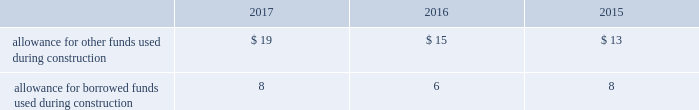Income taxes american water and its subsidiaries participate in a consolidated federal income tax return for u.s .
Tax purposes .
Members of the consolidated group are charged with the amount of federal income tax expense determined as if they filed separate returns .
Certain income and expense items are accounted for in different time periods for financial reporting than for income tax reporting purposes .
The company provides deferred income taxes on the difference between the tax basis of assets and liabilities and the amounts at which they are carried in the financial statements .
These deferred income taxes are based on the enacted tax rates expected to be in effect when these temporary differences are projected to reverse .
In addition , the regulated utility subsidiaries recognize regulatory assets and liabilities for the effect on revenues expected to be realized as the tax effects of temporary differences , previously flowed through to customers , reverse .
Investment tax credits have been deferred by the regulated utility subsidiaries and are being amortized to income over the average estimated service lives of the related assets .
The company recognizes accrued interest and penalties related to tax positions as a component of income tax expense and accounts for sales tax collected from customers and remitted to taxing authorities on a net basis .
See note 13 2014income taxes .
Allowance for funds used during construction afudc is a non-cash credit to income with a corresponding charge to utility plant that represents the cost of borrowed funds or a return on equity funds devoted to plant under construction .
The regulated utility subsidiaries record afudc to the extent permitted by the pucs .
The portion of afudc attributable to borrowed funds is shown as a reduction of interest , net in the accompanying consolidated statements of operations .
Any portion of afudc attributable to equity funds would be included in other income ( expenses ) in the accompanying consolidated statements of operations .
Afudc is summarized in the table for the years ended december 31: .
Environmental costs the company 2019s water and wastewater operations and the operations of its market-based businesses are subject to u.s .
Federal , state , local and foreign requirements relating to environmental protection , and as such , the company periodically becomes subject to environmental claims in the normal course of business .
Environmental expenditures that relate to current operations or provide a future benefit are expensed or capitalized as appropriate .
Remediation costs that relate to an existing condition caused by past operations are accrued , on an undiscounted basis , when it is probable that these costs will be incurred and can be reasonably estimated .
A conservation agreement entered into by a subsidiary of the company with the national oceanic and atmospheric administration in 2010 and amended in 2017 required the company to , among other provisions , implement certain measures to protect the steelhead trout and its habitat in the carmel river watershed in the state of california .
The company agreed to pay $ 1 million annually commencing in 2010 with the final payment being made in 2021 .
Remediation costs accrued amounted to $ 6 million and less than $ 1 million as of december 31 , 2017 and 2016 , respectively .
Derivative financial instruments the company uses derivative financial instruments for purposes of hedging exposures to fluctuations in interest rates .
These derivative contracts are entered into for periods consistent with the related underlying .
What percentage of total afudc in 2016 accounted for allowance for borrowed funds used during construction? 
Computations: (6 / (15 + 6))
Answer: 0.28571. Income taxes american water and its subsidiaries participate in a consolidated federal income tax return for u.s .
Tax purposes .
Members of the consolidated group are charged with the amount of federal income tax expense determined as if they filed separate returns .
Certain income and expense items are accounted for in different time periods for financial reporting than for income tax reporting purposes .
The company provides deferred income taxes on the difference between the tax basis of assets and liabilities and the amounts at which they are carried in the financial statements .
These deferred income taxes are based on the enacted tax rates expected to be in effect when these temporary differences are projected to reverse .
In addition , the regulated utility subsidiaries recognize regulatory assets and liabilities for the effect on revenues expected to be realized as the tax effects of temporary differences , previously flowed through to customers , reverse .
Investment tax credits have been deferred by the regulated utility subsidiaries and are being amortized to income over the average estimated service lives of the related assets .
The company recognizes accrued interest and penalties related to tax positions as a component of income tax expense and accounts for sales tax collected from customers and remitted to taxing authorities on a net basis .
See note 13 2014income taxes .
Allowance for funds used during construction afudc is a non-cash credit to income with a corresponding charge to utility plant that represents the cost of borrowed funds or a return on equity funds devoted to plant under construction .
The regulated utility subsidiaries record afudc to the extent permitted by the pucs .
The portion of afudc attributable to borrowed funds is shown as a reduction of interest , net in the accompanying consolidated statements of operations .
Any portion of afudc attributable to equity funds would be included in other income ( expenses ) in the accompanying consolidated statements of operations .
Afudc is summarized in the table for the years ended december 31: .
Environmental costs the company 2019s water and wastewater operations and the operations of its market-based businesses are subject to u.s .
Federal , state , local and foreign requirements relating to environmental protection , and as such , the company periodically becomes subject to environmental claims in the normal course of business .
Environmental expenditures that relate to current operations or provide a future benefit are expensed or capitalized as appropriate .
Remediation costs that relate to an existing condition caused by past operations are accrued , on an undiscounted basis , when it is probable that these costs will be incurred and can be reasonably estimated .
A conservation agreement entered into by a subsidiary of the company with the national oceanic and atmospheric administration in 2010 and amended in 2017 required the company to , among other provisions , implement certain measures to protect the steelhead trout and its habitat in the carmel river watershed in the state of california .
The company agreed to pay $ 1 million annually commencing in 2010 with the final payment being made in 2021 .
Remediation costs accrued amounted to $ 6 million and less than $ 1 million as of december 31 , 2017 and 2016 , respectively .
Derivative financial instruments the company uses derivative financial instruments for purposes of hedging exposures to fluctuations in interest rates .
These derivative contracts are entered into for periods consistent with the related underlying .
What percentage of total afudc in 2016 accounted for allowance for borrowed funds used during construction? 
Computations: (6 / (15 + 6))
Answer: 0.28571. 